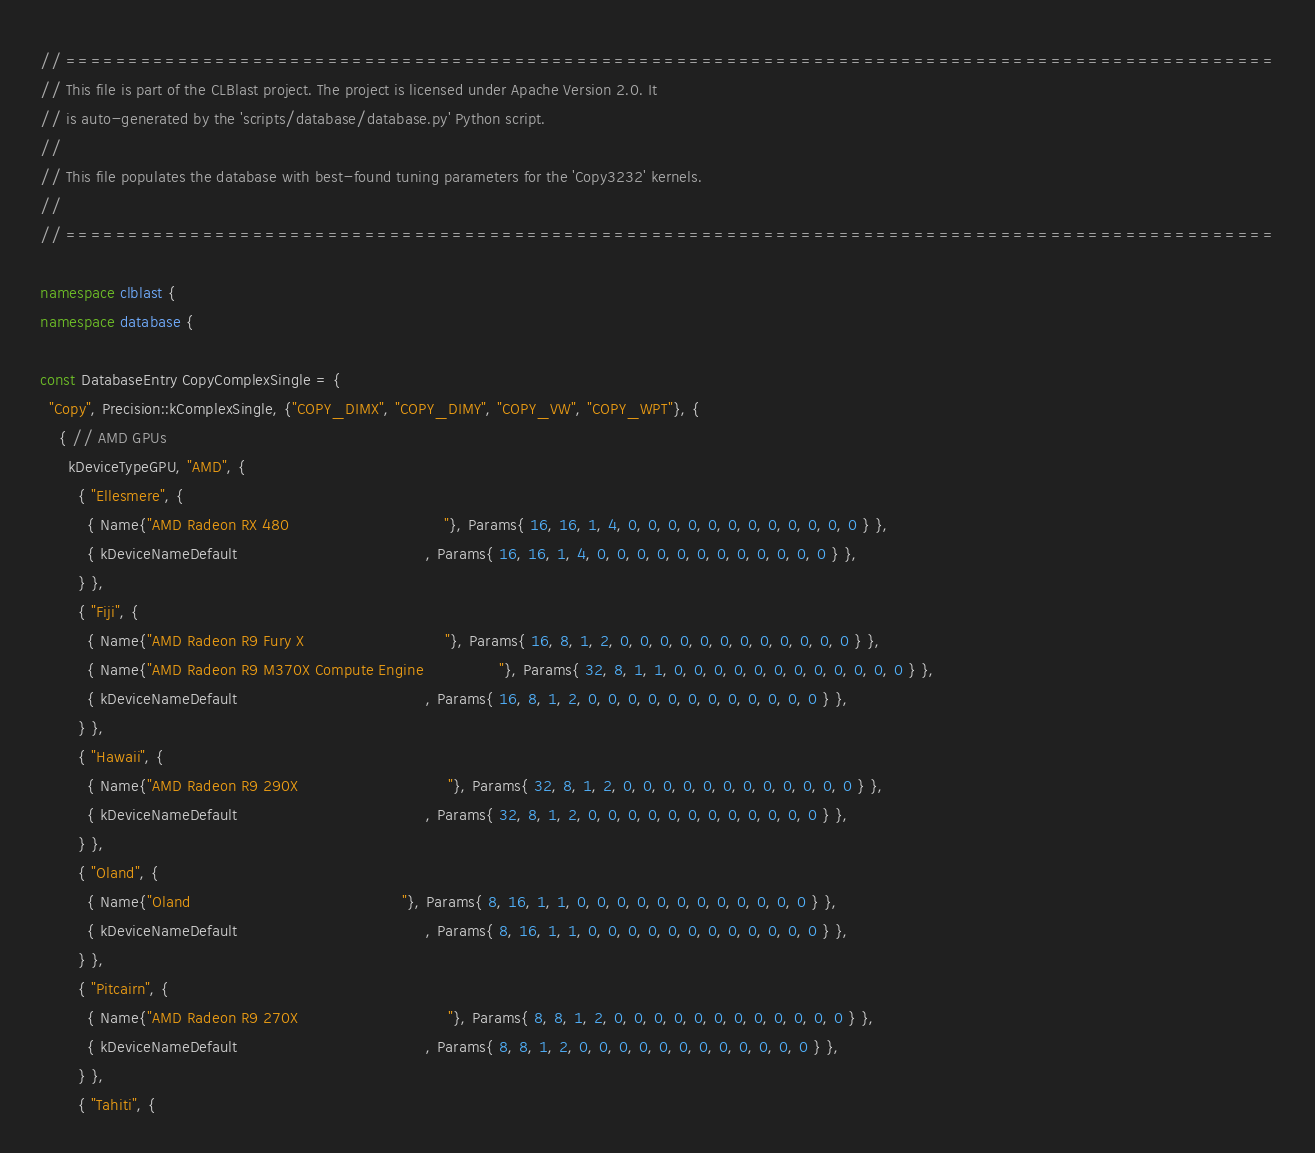Convert code to text. <code><loc_0><loc_0><loc_500><loc_500><_C++_>
// =================================================================================================
// This file is part of the CLBlast project. The project is licensed under Apache Version 2.0. It
// is auto-generated by the 'scripts/database/database.py' Python script.
//
// This file populates the database with best-found tuning parameters for the 'Copy3232' kernels.
//
// =================================================================================================

namespace clblast {
namespace database {

const DatabaseEntry CopyComplexSingle = {
  "Copy", Precision::kComplexSingle, {"COPY_DIMX", "COPY_DIMY", "COPY_VW", "COPY_WPT"}, {
    { // AMD GPUs
      kDeviceTypeGPU, "AMD", {
        { "Ellesmere", {
          { Name{"AMD Radeon RX 480                                 "}, Params{ 16, 16, 1, 4, 0, 0, 0, 0, 0, 0, 0, 0, 0, 0, 0, 0 } },
          { kDeviceNameDefault                                        , Params{ 16, 16, 1, 4, 0, 0, 0, 0, 0, 0, 0, 0, 0, 0, 0, 0 } },
        } },
        { "Fiji", {
          { Name{"AMD Radeon R9 Fury X                              "}, Params{ 16, 8, 1, 2, 0, 0, 0, 0, 0, 0, 0, 0, 0, 0, 0, 0 } },
          { Name{"AMD Radeon R9 M370X Compute Engine                "}, Params{ 32, 8, 1, 1, 0, 0, 0, 0, 0, 0, 0, 0, 0, 0, 0, 0 } },
          { kDeviceNameDefault                                        , Params{ 16, 8, 1, 2, 0, 0, 0, 0, 0, 0, 0, 0, 0, 0, 0, 0 } },
        } },
        { "Hawaii", {
          { Name{"AMD Radeon R9 290X                                "}, Params{ 32, 8, 1, 2, 0, 0, 0, 0, 0, 0, 0, 0, 0, 0, 0, 0 } },
          { kDeviceNameDefault                                        , Params{ 32, 8, 1, 2, 0, 0, 0, 0, 0, 0, 0, 0, 0, 0, 0, 0 } },
        } },
        { "Oland", {
          { Name{"Oland                                             "}, Params{ 8, 16, 1, 1, 0, 0, 0, 0, 0, 0, 0, 0, 0, 0, 0, 0 } },
          { kDeviceNameDefault                                        , Params{ 8, 16, 1, 1, 0, 0, 0, 0, 0, 0, 0, 0, 0, 0, 0, 0 } },
        } },
        { "Pitcairn", {
          { Name{"AMD Radeon R9 270X                                "}, Params{ 8, 8, 1, 2, 0, 0, 0, 0, 0, 0, 0, 0, 0, 0, 0, 0 } },
          { kDeviceNameDefault                                        , Params{ 8, 8, 1, 2, 0, 0, 0, 0, 0, 0, 0, 0, 0, 0, 0, 0 } },
        } },
        { "Tahiti", {</code> 